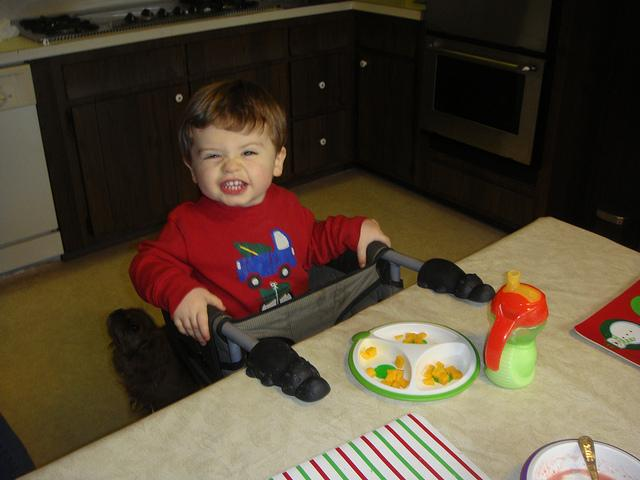What kind of plate is the boy using? plastic 